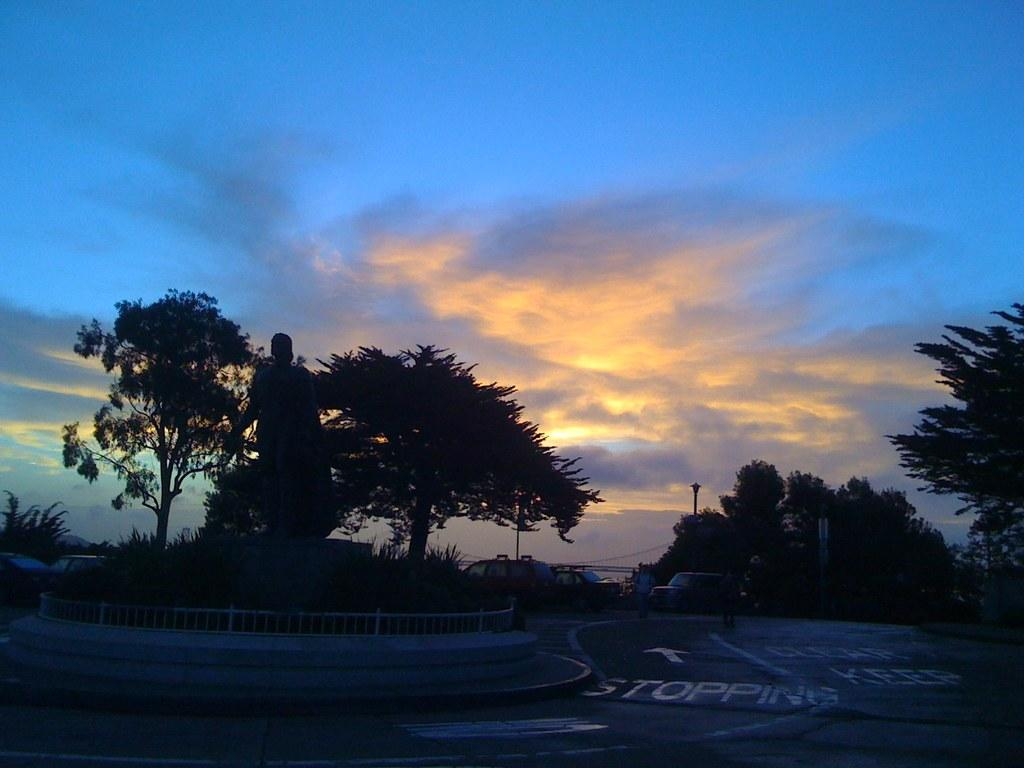What is the main subject in the image? There is a statue in the image. What can be seen near the statue? There is railing in the image. What else is present in the image? There are vehicles, people, text and a symbol on the road, trees, a pole, and the sky with clouds visible in the background. Can you tell me how many eggs are on the statue in the image? There are no eggs present on the statue or in the image. What type of request is being made by the statue in the image? The statue is not making any requests, as it is an inanimate object. 